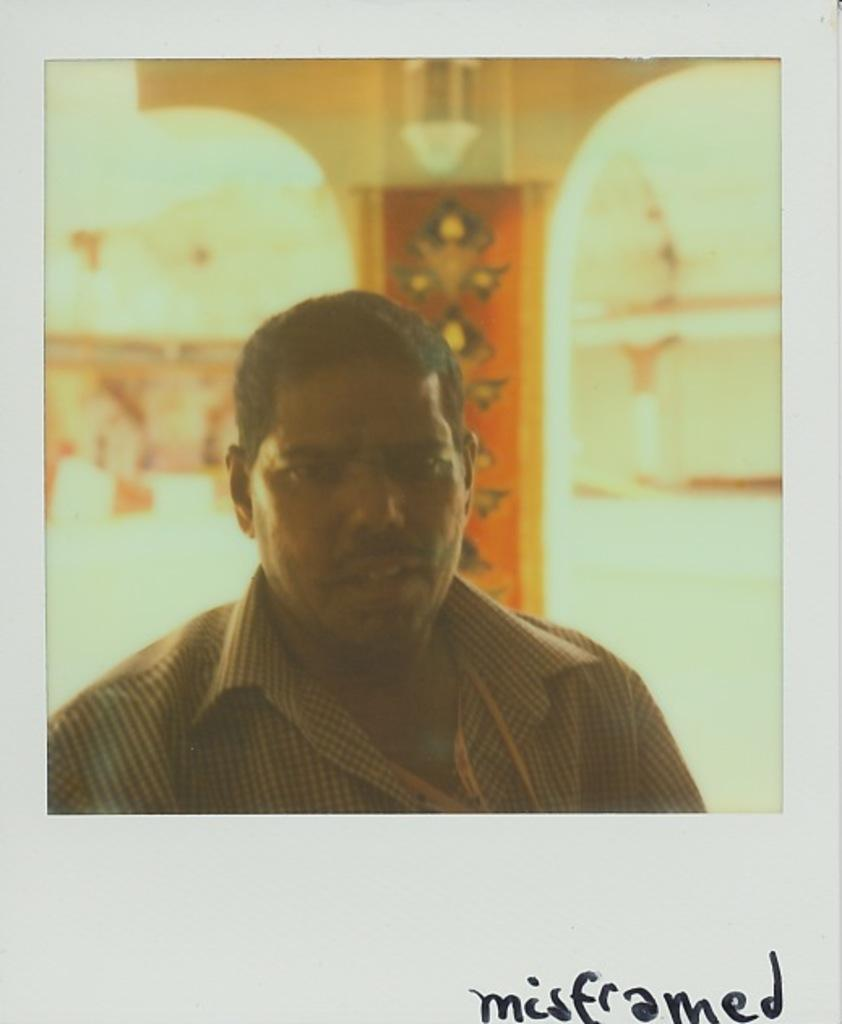What is the main subject of the image? There is a picture of a man in the image. Can you describe the background of the image? There is a pillar in the background of the image. How much does the pig weigh in the image? There is no pig present in the image, so its weight cannot be determined. 